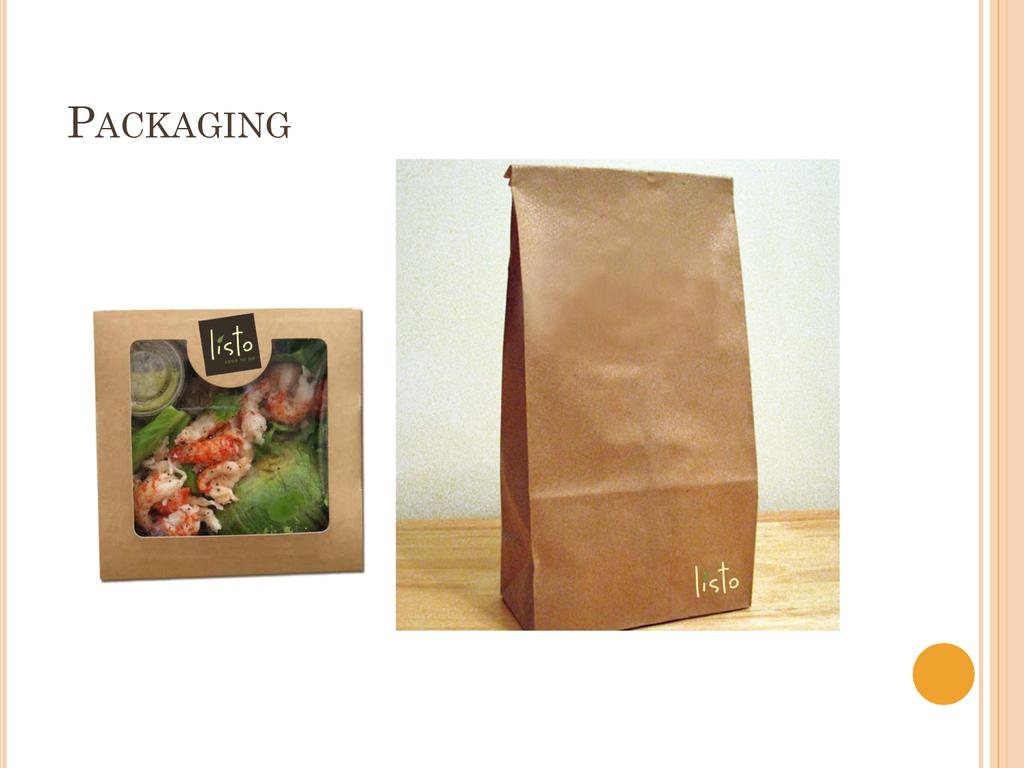What is the main object in the image? There is a slide in the image. What is placed on the slide? There are boxes on the slide. What songs can be heard playing in the background of the image? There is no information about songs or background music in the image. What time of day is it in the image, as indicated by the hour? There is no information about the time of day or any hour in the image. 